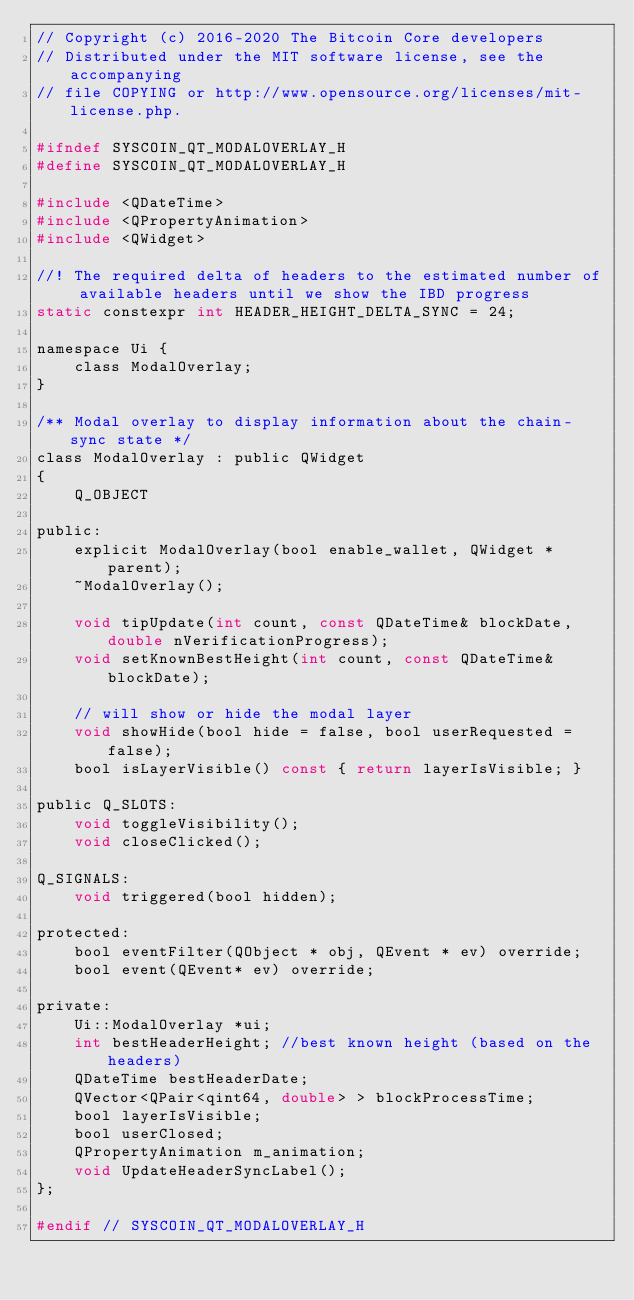Convert code to text. <code><loc_0><loc_0><loc_500><loc_500><_C_>// Copyright (c) 2016-2020 The Bitcoin Core developers
// Distributed under the MIT software license, see the accompanying
// file COPYING or http://www.opensource.org/licenses/mit-license.php.

#ifndef SYSCOIN_QT_MODALOVERLAY_H
#define SYSCOIN_QT_MODALOVERLAY_H

#include <QDateTime>
#include <QPropertyAnimation>
#include <QWidget>

//! The required delta of headers to the estimated number of available headers until we show the IBD progress
static constexpr int HEADER_HEIGHT_DELTA_SYNC = 24;

namespace Ui {
    class ModalOverlay;
}

/** Modal overlay to display information about the chain-sync state */
class ModalOverlay : public QWidget
{
    Q_OBJECT

public:
    explicit ModalOverlay(bool enable_wallet, QWidget *parent);
    ~ModalOverlay();

    void tipUpdate(int count, const QDateTime& blockDate, double nVerificationProgress);
    void setKnownBestHeight(int count, const QDateTime& blockDate);

    // will show or hide the modal layer
    void showHide(bool hide = false, bool userRequested = false);
    bool isLayerVisible() const { return layerIsVisible; }

public Q_SLOTS:
    void toggleVisibility();
    void closeClicked();

Q_SIGNALS:
    void triggered(bool hidden);

protected:
    bool eventFilter(QObject * obj, QEvent * ev) override;
    bool event(QEvent* ev) override;

private:
    Ui::ModalOverlay *ui;
    int bestHeaderHeight; //best known height (based on the headers)
    QDateTime bestHeaderDate;
    QVector<QPair<qint64, double> > blockProcessTime;
    bool layerIsVisible;
    bool userClosed;
    QPropertyAnimation m_animation;
    void UpdateHeaderSyncLabel();
};

#endif // SYSCOIN_QT_MODALOVERLAY_H
</code> 